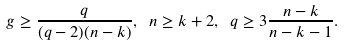<formula> <loc_0><loc_0><loc_500><loc_500>\ g \geq \frac { q } { ( q - 2 ) ( n - k ) } , \ n \geq k + 2 , \ q \geq 3 \frac { n - k } { n - k - 1 } .</formula> 